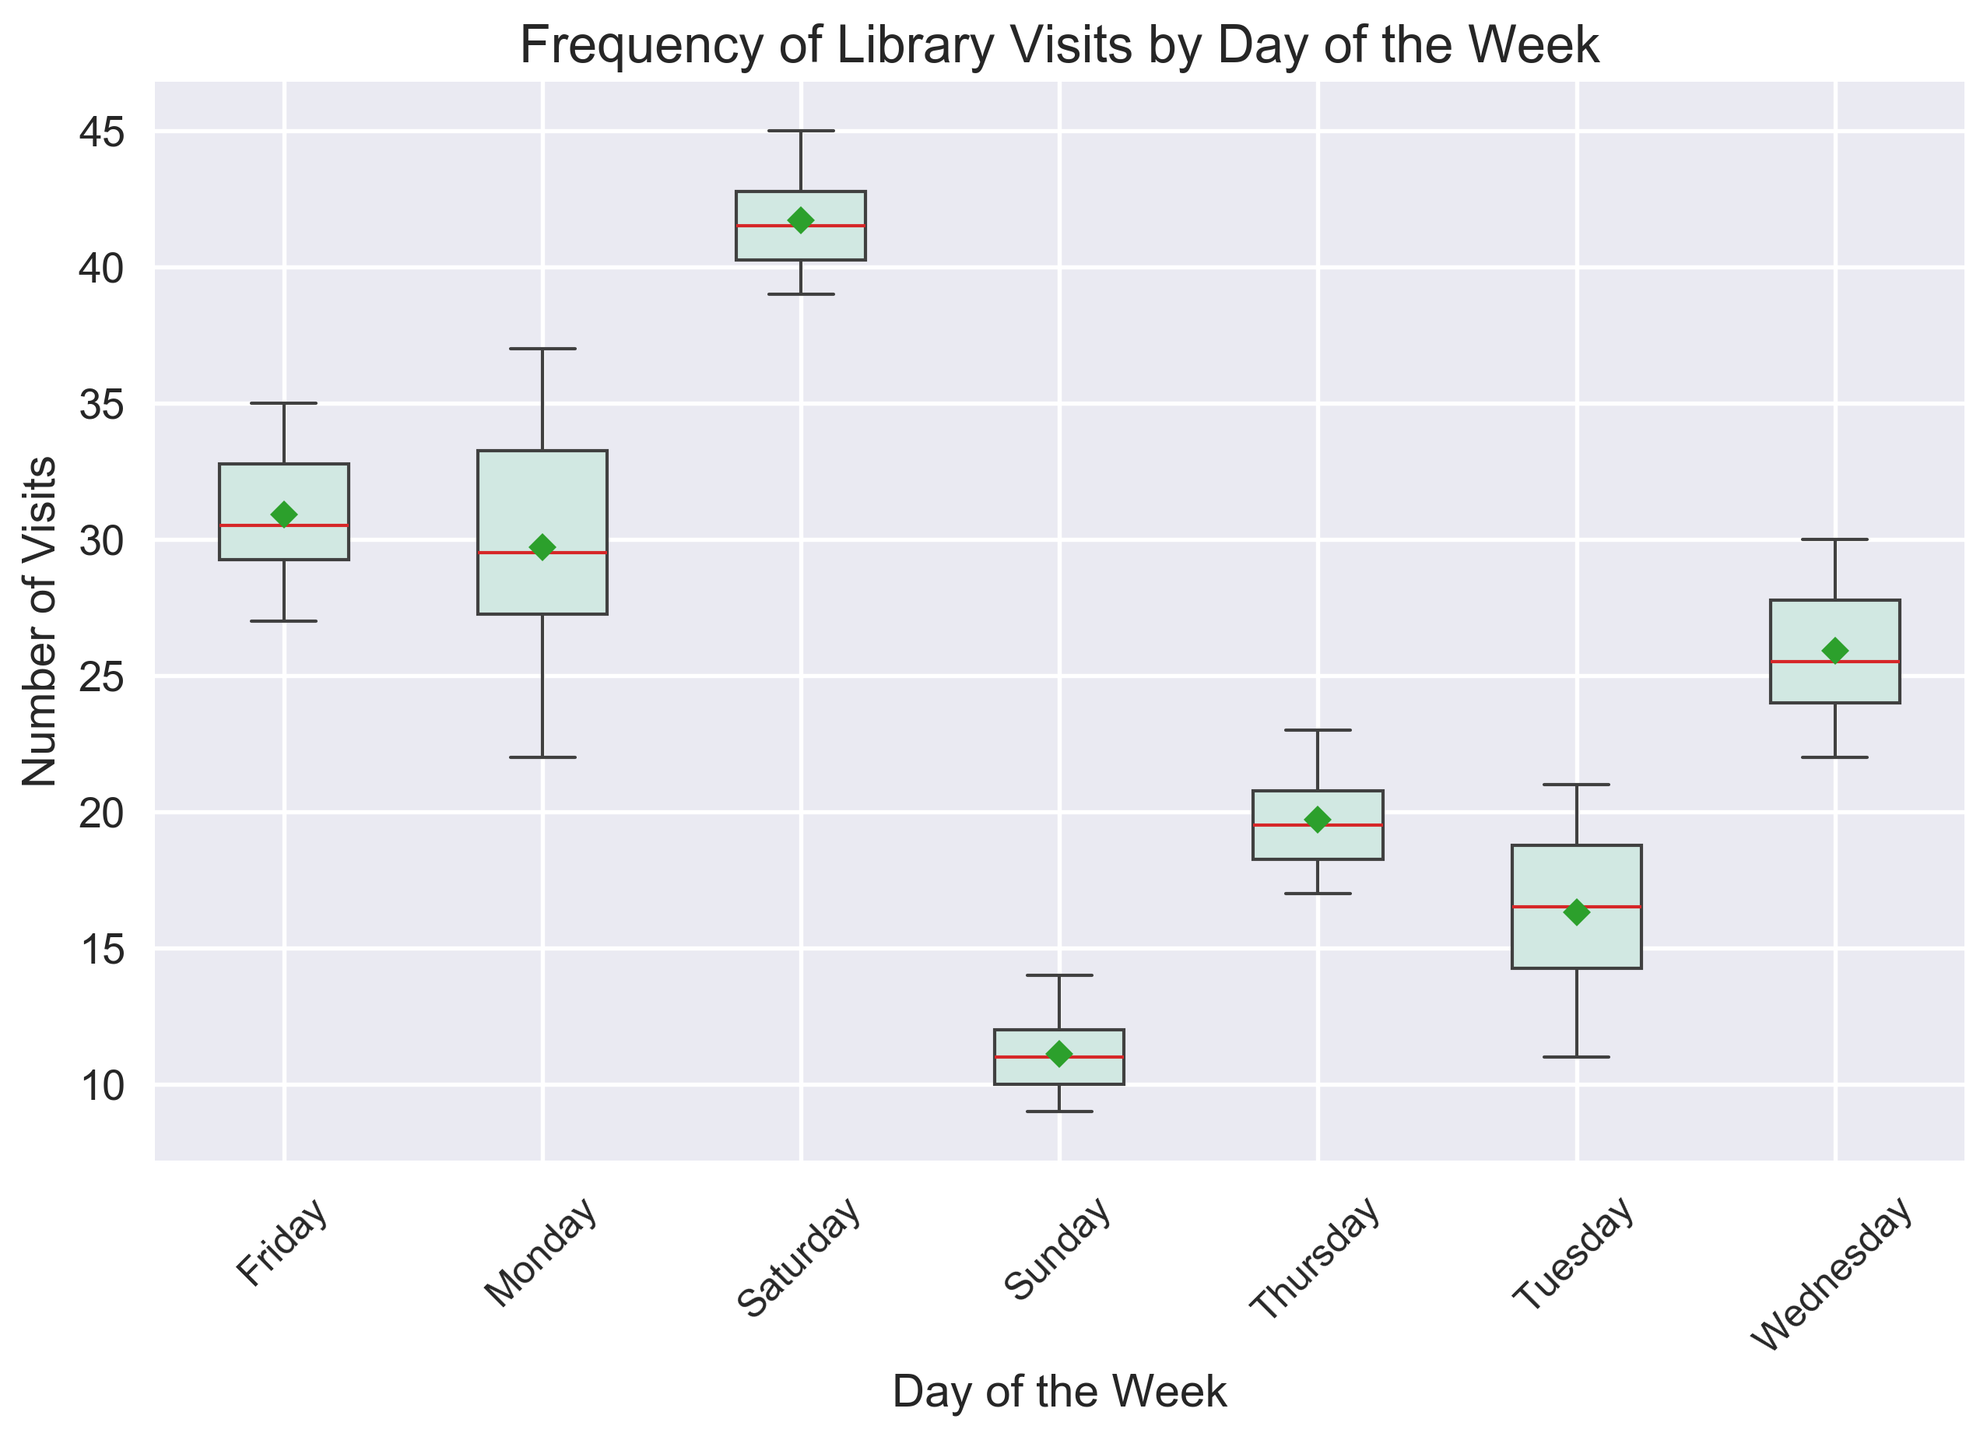What day has the highest median number of visits? First, identify the median lines for each day on the box plot. Saturday has the highest median line indicating it has the highest median number of visits.
Answer: Saturday Which day has the lowest range of visits? The range can be seen by looking at the spread (length) of the boxes and whiskers. Tuesday has the smallest range between the minimum and maximum visit numbers.
Answer: Tuesday What is the mean number of visits on Thursday? Mean values are indicated by a green diamond (or another distinct marker) on the plot. Observe the location of this marker on Thursday to determine the mean number of visits.
Answer: 19.7 Are there any outliers in the data, and if so, which days have them? Outliers are marked by distinct markers outside the whiskers of the box plot. Sunday's lower values around 9 and Saturday's higher values might indicate outliers.
Answer: Sunday, Saturday What is the interquartile range (IQR) for Monday? The IQR is the length of the box in the box plot. The box for Monday spans from the lower quartile (~27) to the upper quartile (~34). Subtracting these gives the IQR. The IQR for Monday would be 34 - 27 = 7.
Answer: 7 Which days have a median number of visits greater than 25? To find this, compare the median lines for each day with the value 25. Monday, Wednesday, Friday, and Saturday all have their median lines above 25.
Answer: Monday, Wednesday, Friday, Saturday On which day is the variability in visits (spread between the whiskers) maximum? The spread between the whiskers indicates variability. Saturday has the whiskers spread the most, showing the highest variability in visits.
Answer: Saturday What is the approximate difference between the median numbers of visits on Friday and Sunday? The median for Friday appears around ~30 and for Sunday around ~11, indicating a difference of approximately 30 - 11 = 19.
Answer: 19 